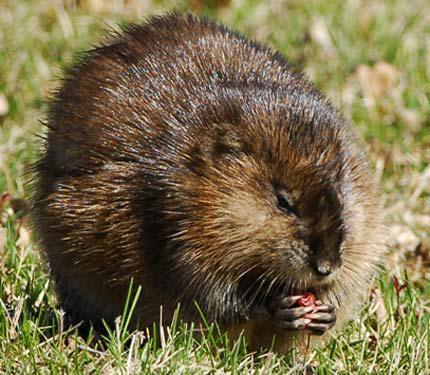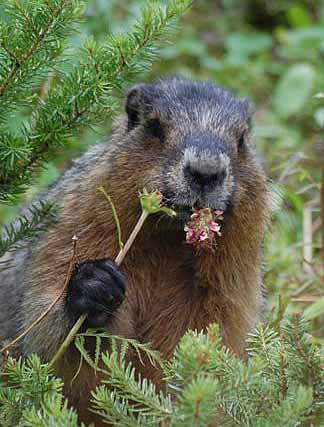The first image is the image on the left, the second image is the image on the right. Analyze the images presented: Is the assertion "At least one animal is eating." valid? Answer yes or no. Yes. The first image is the image on the left, the second image is the image on the right. Given the left and right images, does the statement "There are only two animals and at least one appears to be eating something." hold true? Answer yes or no. Yes. 